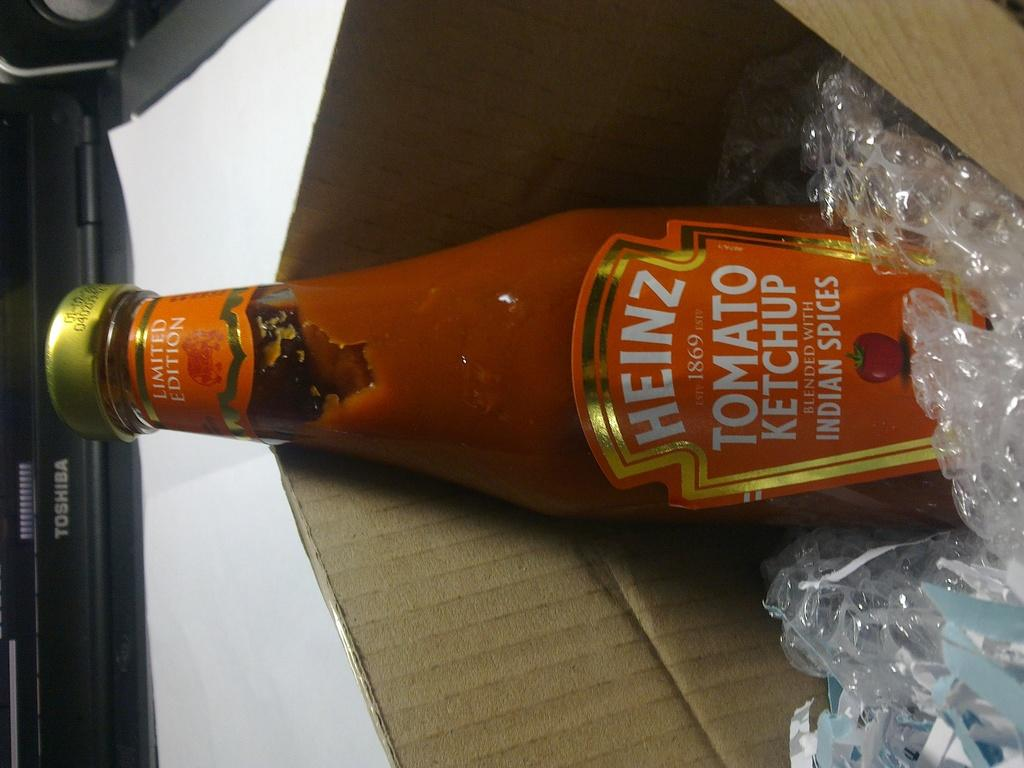<image>
Give a short and clear explanation of the subsequent image. a Heinz tomato ketchup bottle that is in a box 